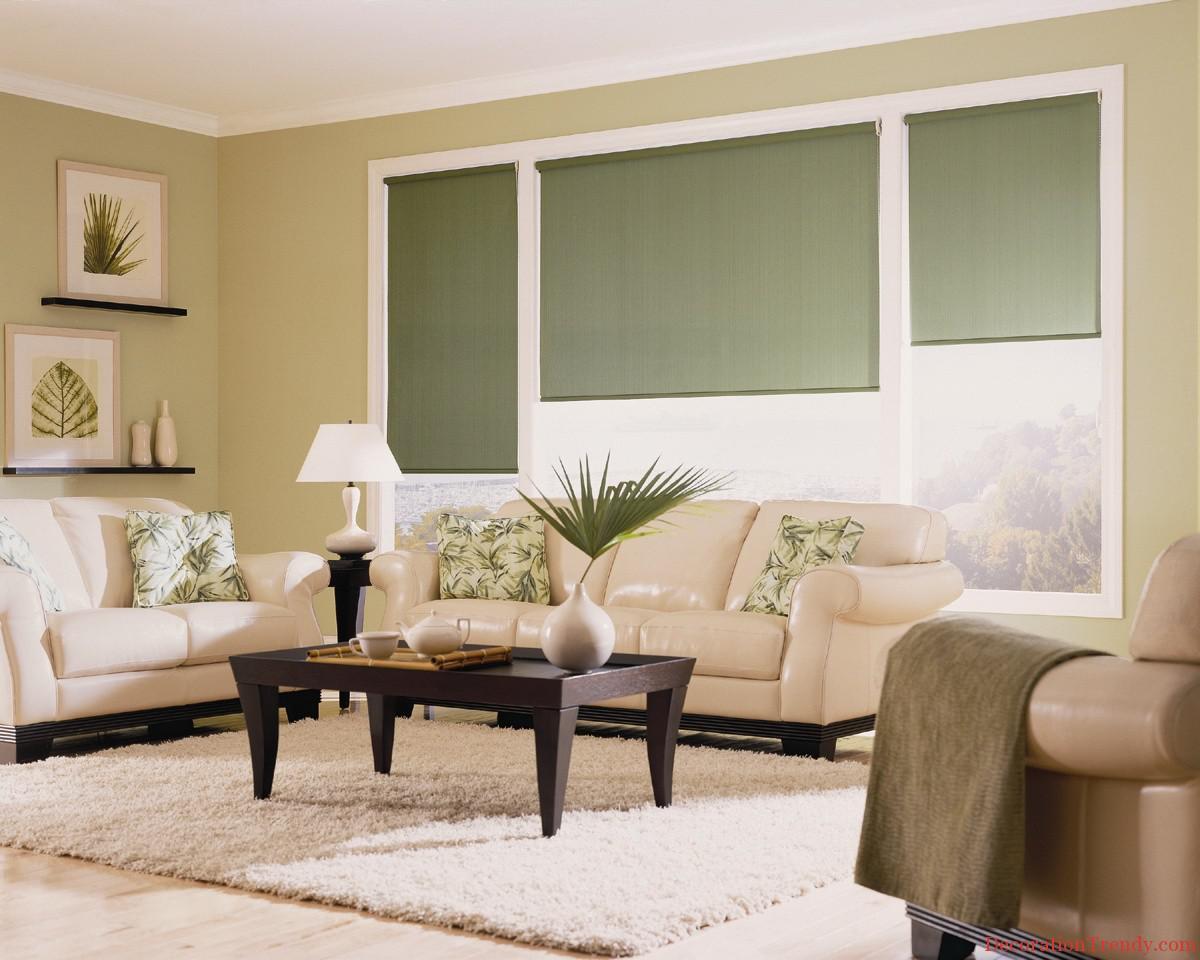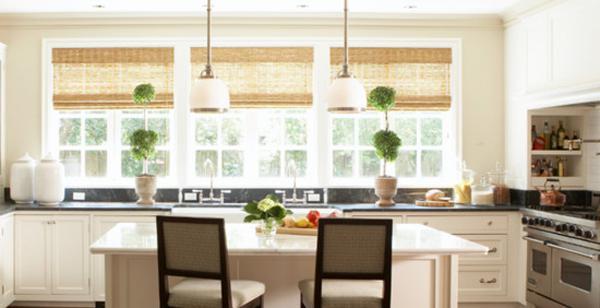The first image is the image on the left, the second image is the image on the right. Given the left and right images, does the statement "A room features a table on a rug in front of a couch, which is in front of windows with three colored shades." hold true? Answer yes or no. Yes. The first image is the image on the left, the second image is the image on the right. For the images displayed, is the sentence "Each image shows three blinds covering three windows side-by-side on the same wall." factually correct? Answer yes or no. Yes. 